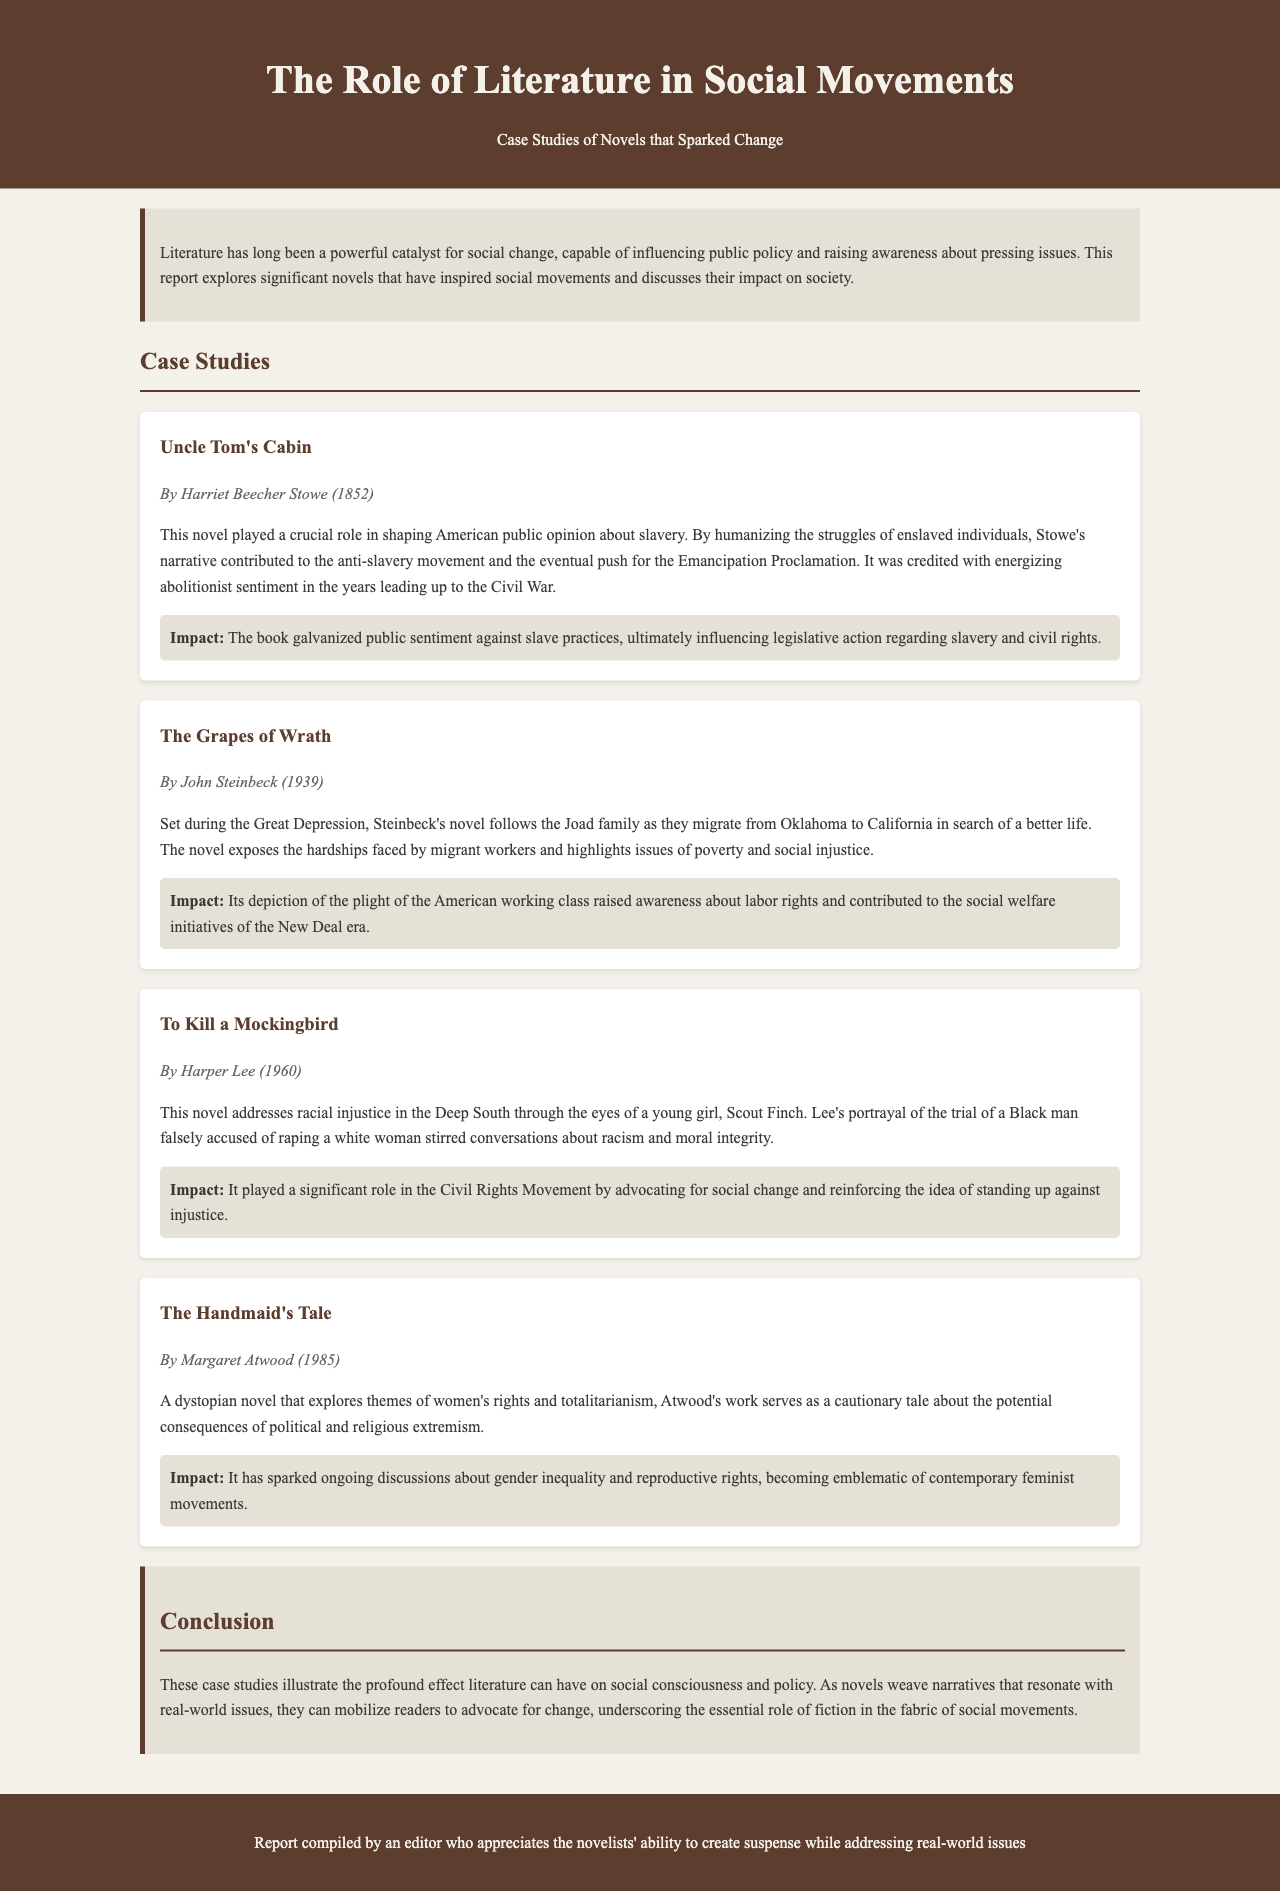What is the title of the report? The title of the report is stated in the header of the document.
Answer: The Role of Literature in Social Movements Who wrote "Uncle Tom's Cabin"? The author's name is provided in the case study section that discusses the novel.
Answer: Harriet Beecher Stowe What year was "The Grapes of Wrath" published? The publication year is clearly mentioned in the case study about the novel.
Answer: 1939 What social issue does "To Kill a Mockingbird" address? The document specifies the main issue that the novel tackles in its summary.
Answer: Racial injustice Which case study is focused on women's rights? The focus of the case study is indicated in the summary of the specific novel.
Answer: The Handmaid's Tale How many case studies are included in the report? By counting the individual case study sections, you can determine the total number presented.
Answer: Four What narrative does "The Grapes of Wrath" depict? The document offers a summary highlighting the plot of the novel.
Answer: The plight of the American working class Which movement did "The Handmaid's Tale" influence? The impact section specifies the movement sparked by the novel.
Answer: Contemporary feminist movements What is the role of literature according to the conclusion? The conclusion summarizes the main argument regarding literature's influence on society.
Answer: Mobilize readers to advocate for change 